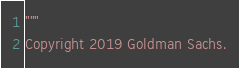Convert code to text. <code><loc_0><loc_0><loc_500><loc_500><_Python_>"""
Copyright 2019 Goldman Sachs.</code> 